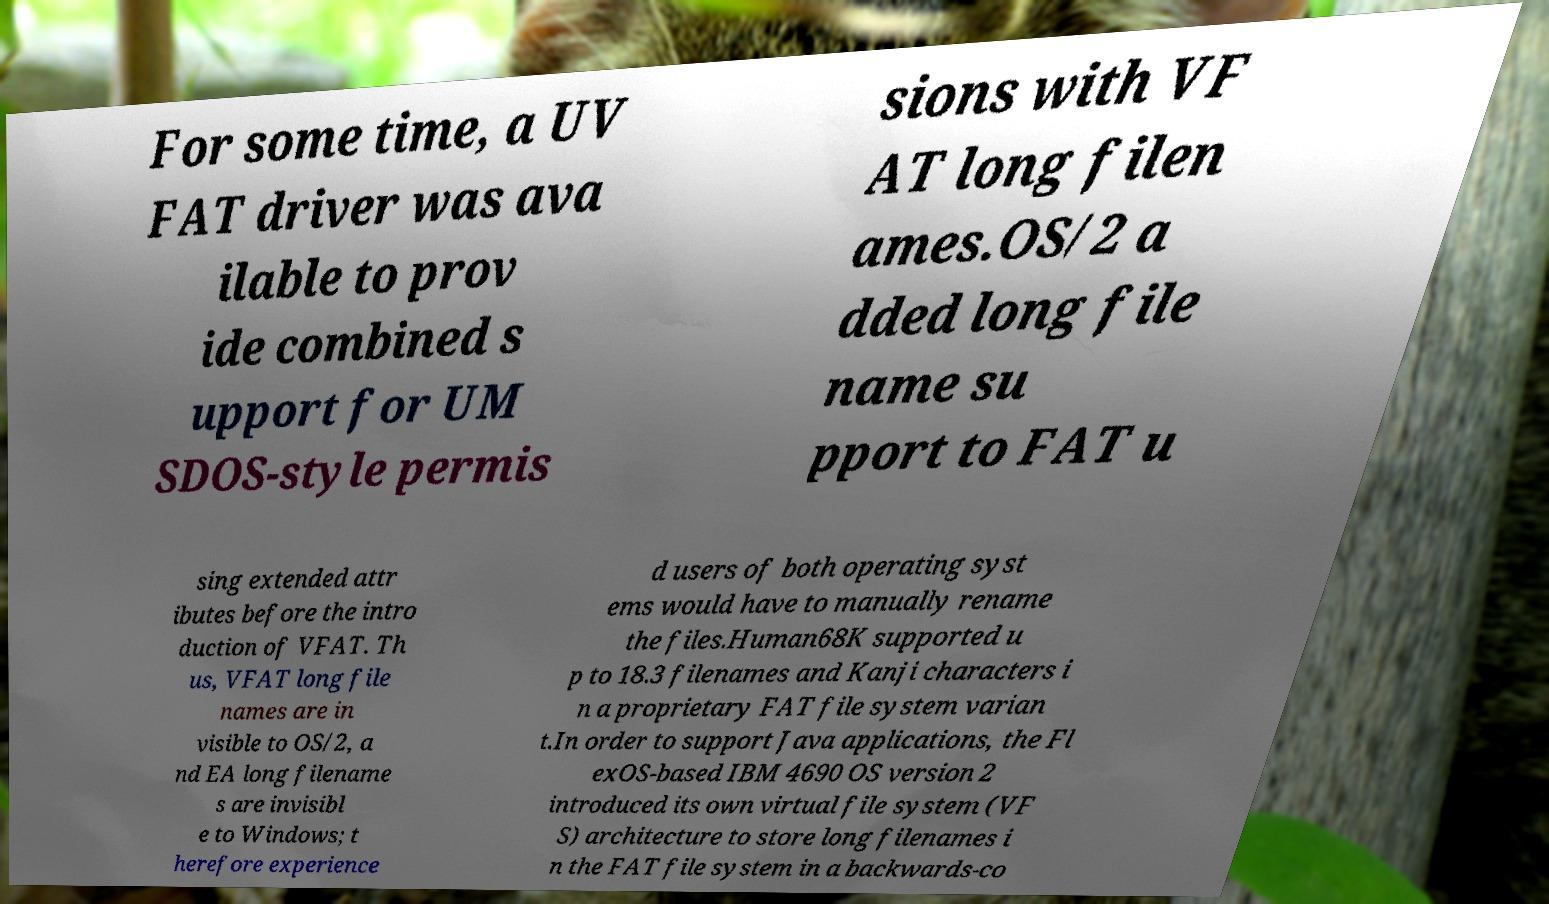Please identify and transcribe the text found in this image. For some time, a UV FAT driver was ava ilable to prov ide combined s upport for UM SDOS-style permis sions with VF AT long filen ames.OS/2 a dded long file name su pport to FAT u sing extended attr ibutes before the intro duction of VFAT. Th us, VFAT long file names are in visible to OS/2, a nd EA long filename s are invisibl e to Windows; t herefore experience d users of both operating syst ems would have to manually rename the files.Human68K supported u p to 18.3 filenames and Kanji characters i n a proprietary FAT file system varian t.In order to support Java applications, the Fl exOS-based IBM 4690 OS version 2 introduced its own virtual file system (VF S) architecture to store long filenames i n the FAT file system in a backwards-co 